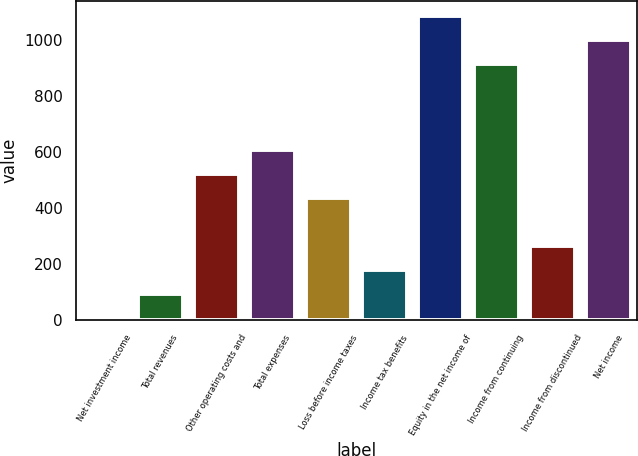Convert chart to OTSL. <chart><loc_0><loc_0><loc_500><loc_500><bar_chart><fcel>Net investment income<fcel>Total revenues<fcel>Other operating costs and<fcel>Total expenses<fcel>Loss before income taxes<fcel>Income tax benefits<fcel>Equity in the net income of<fcel>Income from continuing<fcel>Income from discontinued<fcel>Net income<nl><fcel>6.8<fcel>92.53<fcel>521.18<fcel>606.91<fcel>435.45<fcel>178.26<fcel>1084.49<fcel>913.03<fcel>263.99<fcel>998.76<nl></chart> 